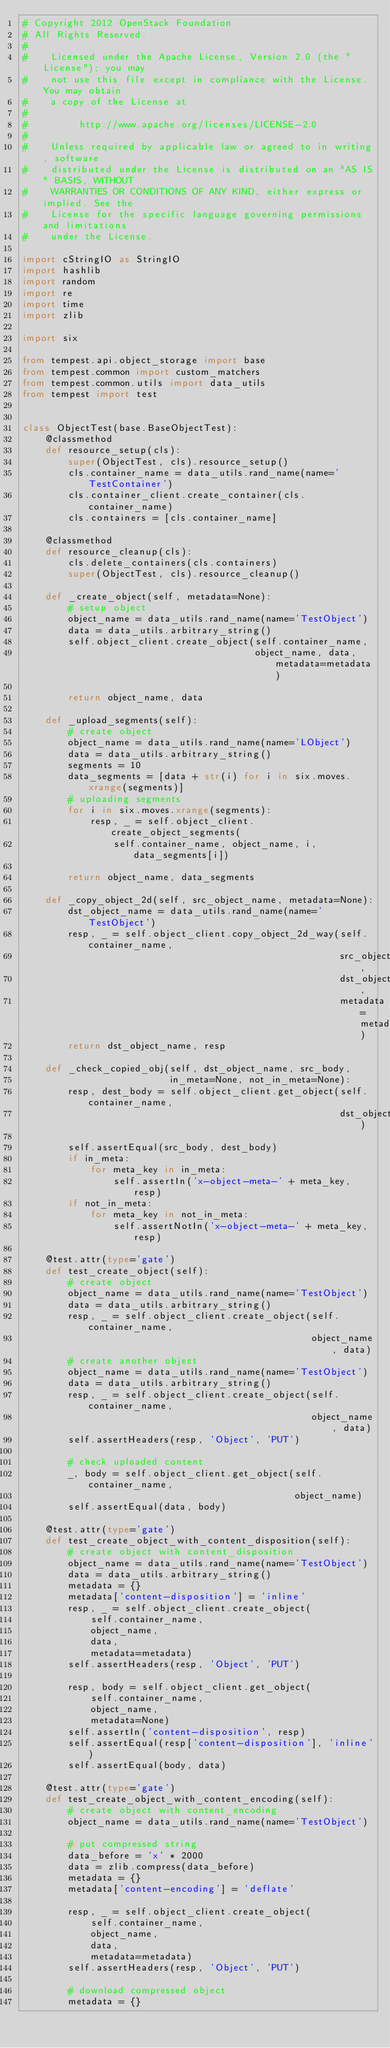Convert code to text. <code><loc_0><loc_0><loc_500><loc_500><_Python_># Copyright 2012 OpenStack Foundation
# All Rights Reserved.
#
#    Licensed under the Apache License, Version 2.0 (the "License"); you may
#    not use this file except in compliance with the License. You may obtain
#    a copy of the License at
#
#         http://www.apache.org/licenses/LICENSE-2.0
#
#    Unless required by applicable law or agreed to in writing, software
#    distributed under the License is distributed on an "AS IS" BASIS, WITHOUT
#    WARRANTIES OR CONDITIONS OF ANY KIND, either express or implied. See the
#    License for the specific language governing permissions and limitations
#    under the License.

import cStringIO as StringIO
import hashlib
import random
import re
import time
import zlib

import six

from tempest.api.object_storage import base
from tempest.common import custom_matchers
from tempest.common.utils import data_utils
from tempest import test


class ObjectTest(base.BaseObjectTest):
    @classmethod
    def resource_setup(cls):
        super(ObjectTest, cls).resource_setup()
        cls.container_name = data_utils.rand_name(name='TestContainer')
        cls.container_client.create_container(cls.container_name)
        cls.containers = [cls.container_name]

    @classmethod
    def resource_cleanup(cls):
        cls.delete_containers(cls.containers)
        super(ObjectTest, cls).resource_cleanup()

    def _create_object(self, metadata=None):
        # setup object
        object_name = data_utils.rand_name(name='TestObject')
        data = data_utils.arbitrary_string()
        self.object_client.create_object(self.container_name,
                                         object_name, data, metadata=metadata)

        return object_name, data

    def _upload_segments(self):
        # create object
        object_name = data_utils.rand_name(name='LObject')
        data = data_utils.arbitrary_string()
        segments = 10
        data_segments = [data + str(i) for i in six.moves.xrange(segments)]
        # uploading segments
        for i in six.moves.xrange(segments):
            resp, _ = self.object_client.create_object_segments(
                self.container_name, object_name, i, data_segments[i])

        return object_name, data_segments

    def _copy_object_2d(self, src_object_name, metadata=None):
        dst_object_name = data_utils.rand_name(name='TestObject')
        resp, _ = self.object_client.copy_object_2d_way(self.container_name,
                                                        src_object_name,
                                                        dst_object_name,
                                                        metadata=metadata)
        return dst_object_name, resp

    def _check_copied_obj(self, dst_object_name, src_body,
                          in_meta=None, not_in_meta=None):
        resp, dest_body = self.object_client.get_object(self.container_name,
                                                        dst_object_name)

        self.assertEqual(src_body, dest_body)
        if in_meta:
            for meta_key in in_meta:
                self.assertIn('x-object-meta-' + meta_key, resp)
        if not_in_meta:
            for meta_key in not_in_meta:
                self.assertNotIn('x-object-meta-' + meta_key, resp)

    @test.attr(type='gate')
    def test_create_object(self):
        # create object
        object_name = data_utils.rand_name(name='TestObject')
        data = data_utils.arbitrary_string()
        resp, _ = self.object_client.create_object(self.container_name,
                                                   object_name, data)
        # create another object
        object_name = data_utils.rand_name(name='TestObject')
        data = data_utils.arbitrary_string()
        resp, _ = self.object_client.create_object(self.container_name,
                                                   object_name, data)
        self.assertHeaders(resp, 'Object', 'PUT')

        # check uploaded content
        _, body = self.object_client.get_object(self.container_name,
                                                object_name)
        self.assertEqual(data, body)

    @test.attr(type='gate')
    def test_create_object_with_content_disposition(self):
        # create object with content_disposition
        object_name = data_utils.rand_name(name='TestObject')
        data = data_utils.arbitrary_string()
        metadata = {}
        metadata['content-disposition'] = 'inline'
        resp, _ = self.object_client.create_object(
            self.container_name,
            object_name,
            data,
            metadata=metadata)
        self.assertHeaders(resp, 'Object', 'PUT')

        resp, body = self.object_client.get_object(
            self.container_name,
            object_name,
            metadata=None)
        self.assertIn('content-disposition', resp)
        self.assertEqual(resp['content-disposition'], 'inline')
        self.assertEqual(body, data)

    @test.attr(type='gate')
    def test_create_object_with_content_encoding(self):
        # create object with content_encoding
        object_name = data_utils.rand_name(name='TestObject')

        # put compressed string
        data_before = 'x' * 2000
        data = zlib.compress(data_before)
        metadata = {}
        metadata['content-encoding'] = 'deflate'

        resp, _ = self.object_client.create_object(
            self.container_name,
            object_name,
            data,
            metadata=metadata)
        self.assertHeaders(resp, 'Object', 'PUT')

        # download compressed object
        metadata = {}</code> 